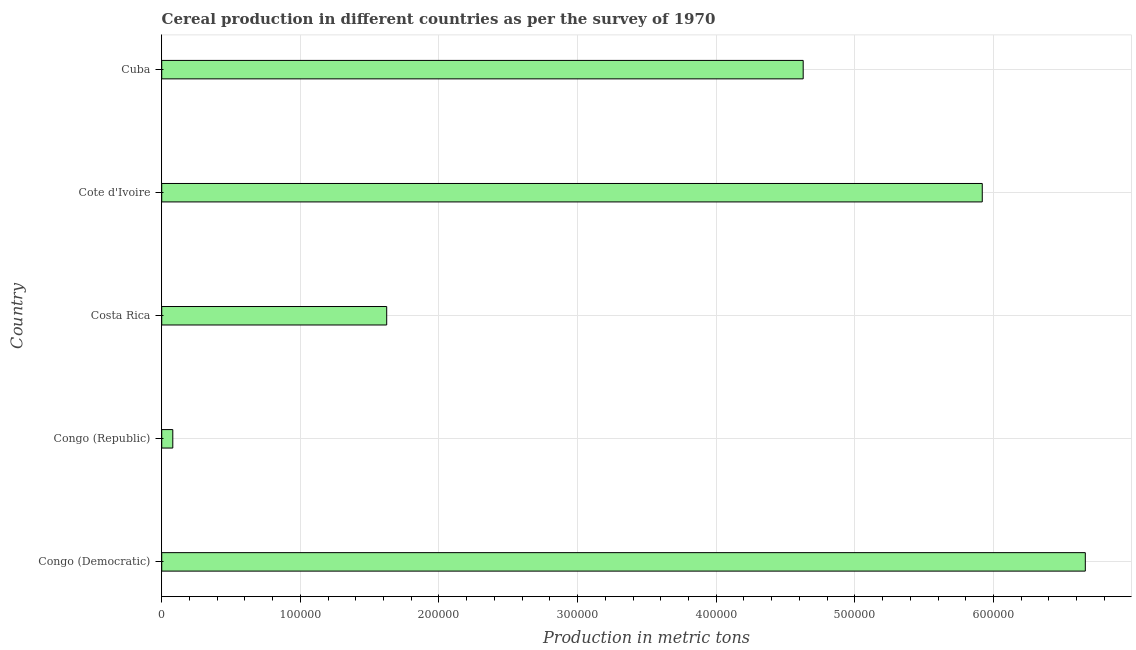Does the graph contain any zero values?
Your response must be concise. No. Does the graph contain grids?
Your answer should be compact. Yes. What is the title of the graph?
Ensure brevity in your answer.  Cereal production in different countries as per the survey of 1970. What is the label or title of the X-axis?
Keep it short and to the point. Production in metric tons. What is the cereal production in Congo (Republic)?
Give a very brief answer. 8000. Across all countries, what is the maximum cereal production?
Ensure brevity in your answer.  6.66e+05. Across all countries, what is the minimum cereal production?
Your response must be concise. 8000. In which country was the cereal production maximum?
Keep it short and to the point. Congo (Democratic). In which country was the cereal production minimum?
Provide a short and direct response. Congo (Republic). What is the sum of the cereal production?
Your response must be concise. 1.89e+06. What is the difference between the cereal production in Congo (Democratic) and Cuba?
Provide a short and direct response. 2.04e+05. What is the average cereal production per country?
Ensure brevity in your answer.  3.78e+05. What is the median cereal production?
Provide a short and direct response. 4.63e+05. In how many countries, is the cereal production greater than 500000 metric tons?
Offer a terse response. 2. What is the ratio of the cereal production in Congo (Republic) to that in Cuba?
Your answer should be compact. 0.02. Is the cereal production in Congo (Republic) less than that in Cote d'Ivoire?
Your answer should be compact. Yes. Is the difference between the cereal production in Congo (Democratic) and Cote d'Ivoire greater than the difference between any two countries?
Ensure brevity in your answer.  No. What is the difference between the highest and the second highest cereal production?
Your response must be concise. 7.43e+04. Is the sum of the cereal production in Congo (Republic) and Costa Rica greater than the maximum cereal production across all countries?
Make the answer very short. No. What is the difference between the highest and the lowest cereal production?
Your response must be concise. 6.58e+05. In how many countries, is the cereal production greater than the average cereal production taken over all countries?
Provide a succinct answer. 3. How many bars are there?
Offer a very short reply. 5. Are all the bars in the graph horizontal?
Your response must be concise. Yes. What is the difference between two consecutive major ticks on the X-axis?
Offer a very short reply. 1.00e+05. Are the values on the major ticks of X-axis written in scientific E-notation?
Your response must be concise. No. What is the Production in metric tons in Congo (Democratic)?
Give a very brief answer. 6.66e+05. What is the Production in metric tons in Congo (Republic)?
Offer a terse response. 8000. What is the Production in metric tons in Costa Rica?
Make the answer very short. 1.62e+05. What is the Production in metric tons of Cote d'Ivoire?
Ensure brevity in your answer.  5.92e+05. What is the Production in metric tons of Cuba?
Provide a succinct answer. 4.63e+05. What is the difference between the Production in metric tons in Congo (Democratic) and Congo (Republic)?
Offer a very short reply. 6.58e+05. What is the difference between the Production in metric tons in Congo (Democratic) and Costa Rica?
Give a very brief answer. 5.04e+05. What is the difference between the Production in metric tons in Congo (Democratic) and Cote d'Ivoire?
Make the answer very short. 7.43e+04. What is the difference between the Production in metric tons in Congo (Democratic) and Cuba?
Provide a succinct answer. 2.04e+05. What is the difference between the Production in metric tons in Congo (Republic) and Costa Rica?
Ensure brevity in your answer.  -1.54e+05. What is the difference between the Production in metric tons in Congo (Republic) and Cote d'Ivoire?
Your response must be concise. -5.84e+05. What is the difference between the Production in metric tons in Congo (Republic) and Cuba?
Give a very brief answer. -4.55e+05. What is the difference between the Production in metric tons in Costa Rica and Cote d'Ivoire?
Offer a terse response. -4.30e+05. What is the difference between the Production in metric tons in Costa Rica and Cuba?
Your answer should be compact. -3.00e+05. What is the difference between the Production in metric tons in Cote d'Ivoire and Cuba?
Provide a succinct answer. 1.29e+05. What is the ratio of the Production in metric tons in Congo (Democratic) to that in Congo (Republic)?
Your response must be concise. 83.28. What is the ratio of the Production in metric tons in Congo (Democratic) to that in Costa Rica?
Your response must be concise. 4.11. What is the ratio of the Production in metric tons in Congo (Democratic) to that in Cote d'Ivoire?
Your answer should be compact. 1.13. What is the ratio of the Production in metric tons in Congo (Democratic) to that in Cuba?
Your response must be concise. 1.44. What is the ratio of the Production in metric tons in Congo (Republic) to that in Costa Rica?
Provide a short and direct response. 0.05. What is the ratio of the Production in metric tons in Congo (Republic) to that in Cote d'Ivoire?
Offer a terse response. 0.01. What is the ratio of the Production in metric tons in Congo (Republic) to that in Cuba?
Your answer should be compact. 0.02. What is the ratio of the Production in metric tons in Costa Rica to that in Cote d'Ivoire?
Your response must be concise. 0.27. What is the ratio of the Production in metric tons in Costa Rica to that in Cuba?
Provide a succinct answer. 0.35. What is the ratio of the Production in metric tons in Cote d'Ivoire to that in Cuba?
Provide a short and direct response. 1.28. 